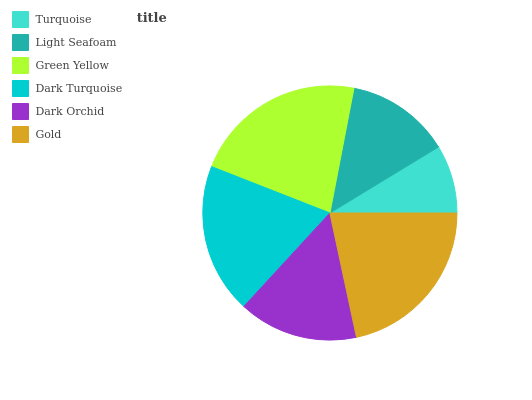Is Turquoise the minimum?
Answer yes or no. Yes. Is Green Yellow the maximum?
Answer yes or no. Yes. Is Light Seafoam the minimum?
Answer yes or no. No. Is Light Seafoam the maximum?
Answer yes or no. No. Is Light Seafoam greater than Turquoise?
Answer yes or no. Yes. Is Turquoise less than Light Seafoam?
Answer yes or no. Yes. Is Turquoise greater than Light Seafoam?
Answer yes or no. No. Is Light Seafoam less than Turquoise?
Answer yes or no. No. Is Dark Turquoise the high median?
Answer yes or no. Yes. Is Dark Orchid the low median?
Answer yes or no. Yes. Is Gold the high median?
Answer yes or no. No. Is Light Seafoam the low median?
Answer yes or no. No. 